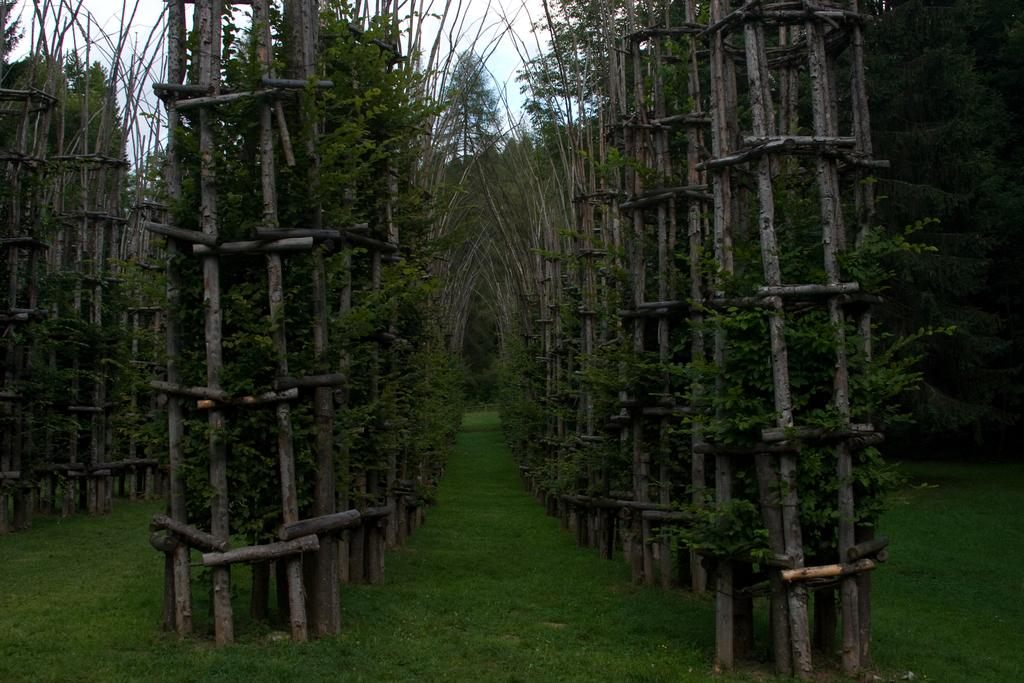What type of vegetation is present in the image? There are many plants and trees in the image. What is the ground covered with in the image? There is grass at the bottom of the image. What type of objects can be seen made of wood in the image? There are wooden objects in the image. What can be seen in the background of the image? The sky is visible in the background of the image. What type of dress is hanging on the tree in the image? There is no dress present in the image; it features plants, trees, wooden objects, grass, and the sky. What type of grain can be seen growing in the image? There is no grain present in the image; it features plants, trees, wooden objects, grass, and the sky. 